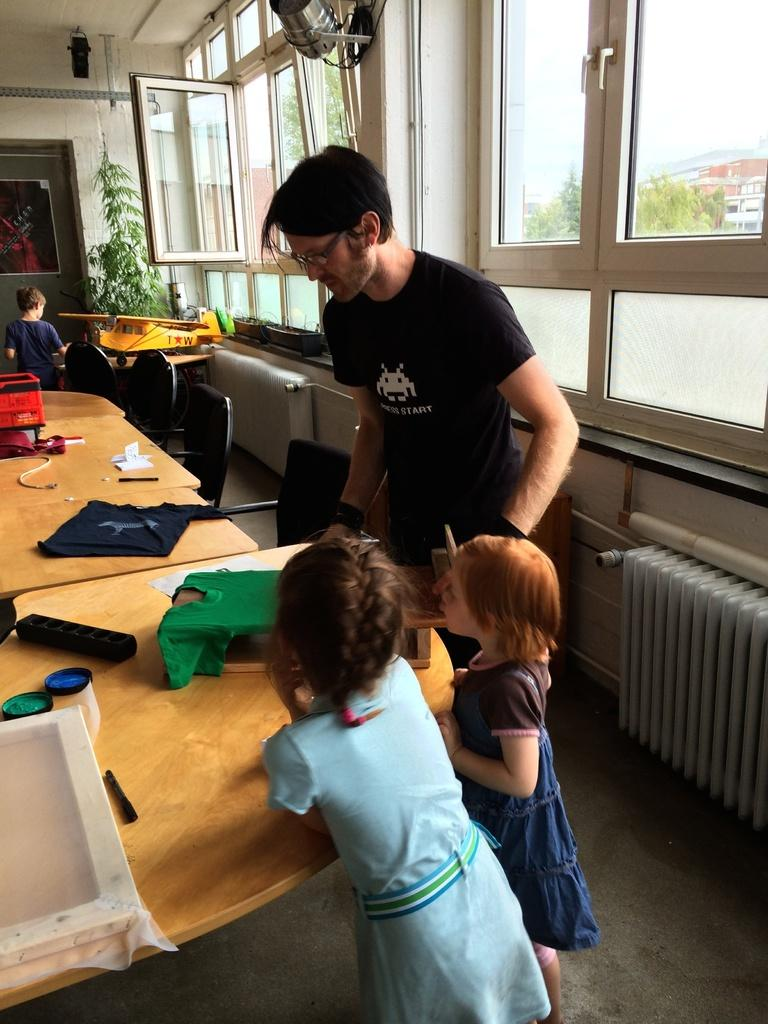What can be seen through the window in the image? The facts provided do not specify what can be seen through the window. What type of plant is in the image? The facts provided do not specify the type of plant in the image. What is the wall made of in the image? The facts provided do not specify the material of the wall in the image. How many people are present in the image? There are people present in the image, but the exact number is not specified. What is on the table in the image? There is a cloth on the table in the image. What type of dress is the woman wearing in the image? There is no woman present in the image, so it is not possible to answer this question. Who is the representative in the image? There is no mention of a representative in the image. 